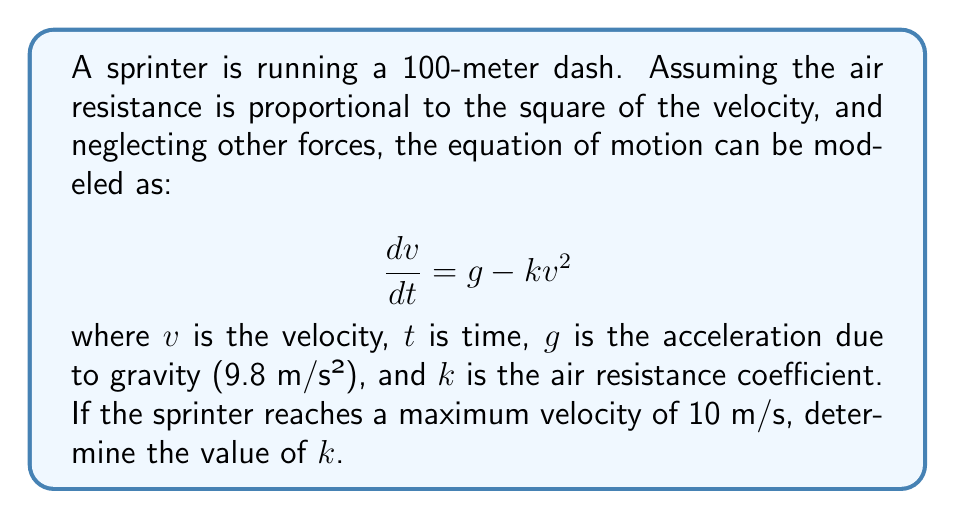Could you help me with this problem? To solve this problem, we need to follow these steps:

1) At maximum velocity, acceleration is zero. Therefore, $\frac{dv}{dt} = 0$.

2) Substituting this into our equation:

   $$0 = g - kv_{max}^2$$

3) We know $g = 9.8$ m/s² and $v_{max} = 10$ m/s. Let's substitute these values:

   $$0 = 9.8 - k(10)^2$$

4) Simplify:

   $$0 = 9.8 - 100k$$

5) Solve for $k$:

   $$100k = 9.8$$
   $$k = \frac{9.8}{100} = 0.098$$

Therefore, the air resistance coefficient $k$ is 0.098 s²/m².

This value of $k$ represents the effect of air resistance on the sprinter's maximum speed. A lower value would indicate less air resistance, potentially due to factors like the sprinter's body position or the design of their running gear. As a professional sprinter dealing with supplement issues, understanding these factors could be crucial for optimizing performance within legal limits.
Answer: $k = 0.098$ s²/m² 